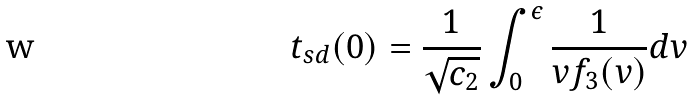<formula> <loc_0><loc_0><loc_500><loc_500>t _ { s d } ( 0 ) = \frac { 1 } { \sqrt { c _ { 2 } } } \int _ { 0 } ^ { \epsilon } \frac { 1 } { v f _ { 3 } ( v ) } d v</formula> 